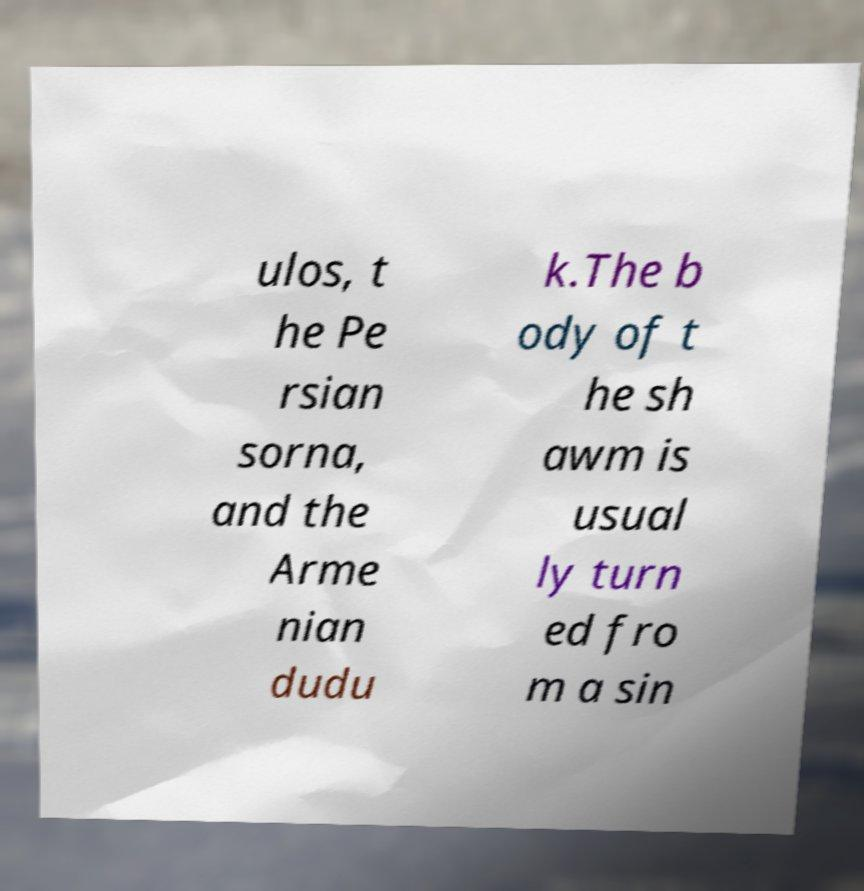Could you extract and type out the text from this image? ulos, t he Pe rsian sorna, and the Arme nian dudu k.The b ody of t he sh awm is usual ly turn ed fro m a sin 